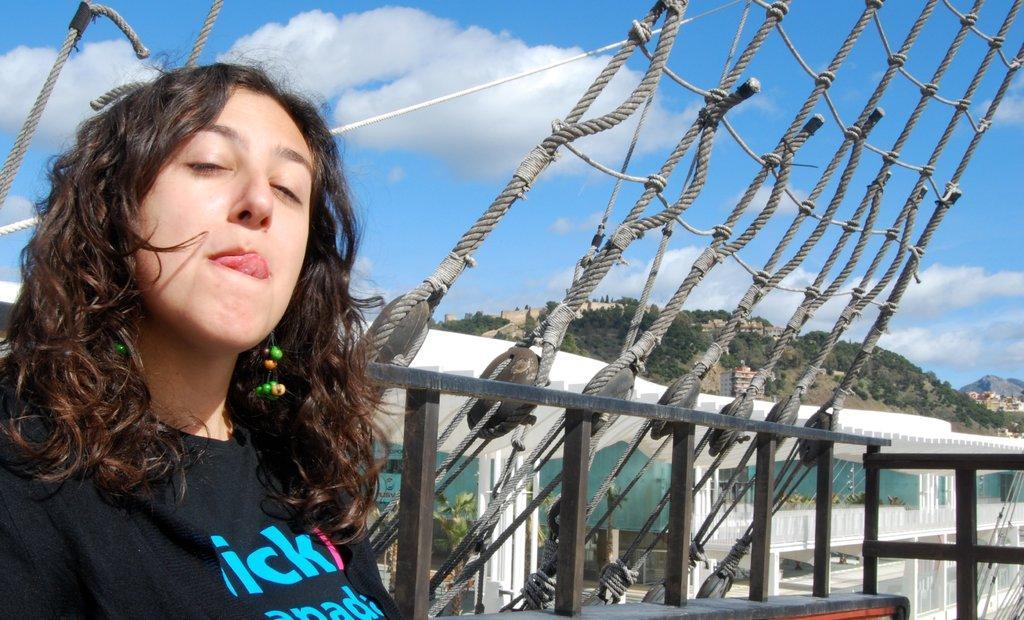In one or two sentences, can you explain what this image depicts? In this image we can see a woman on the left side and we can see metal rods with ropes attached to it. In the background, we can see a building and some trees and we can also see the mountains. At the top, we can see the sky. 